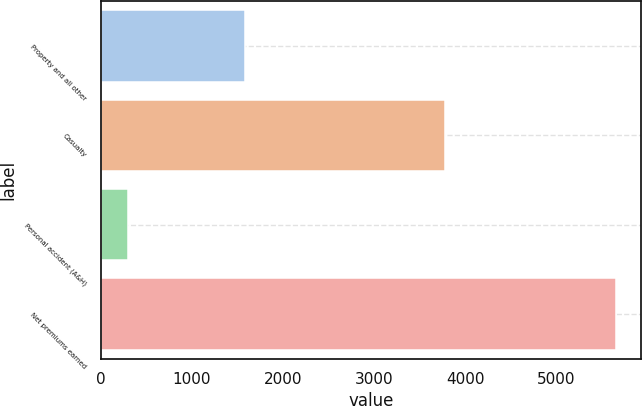Convert chart. <chart><loc_0><loc_0><loc_500><loc_500><bar_chart><fcel>Property and all other<fcel>Casualty<fcel>Personal accident (A&H)<fcel>Net premiums earned<nl><fcel>1578<fcel>3777<fcel>296<fcel>5651<nl></chart> 